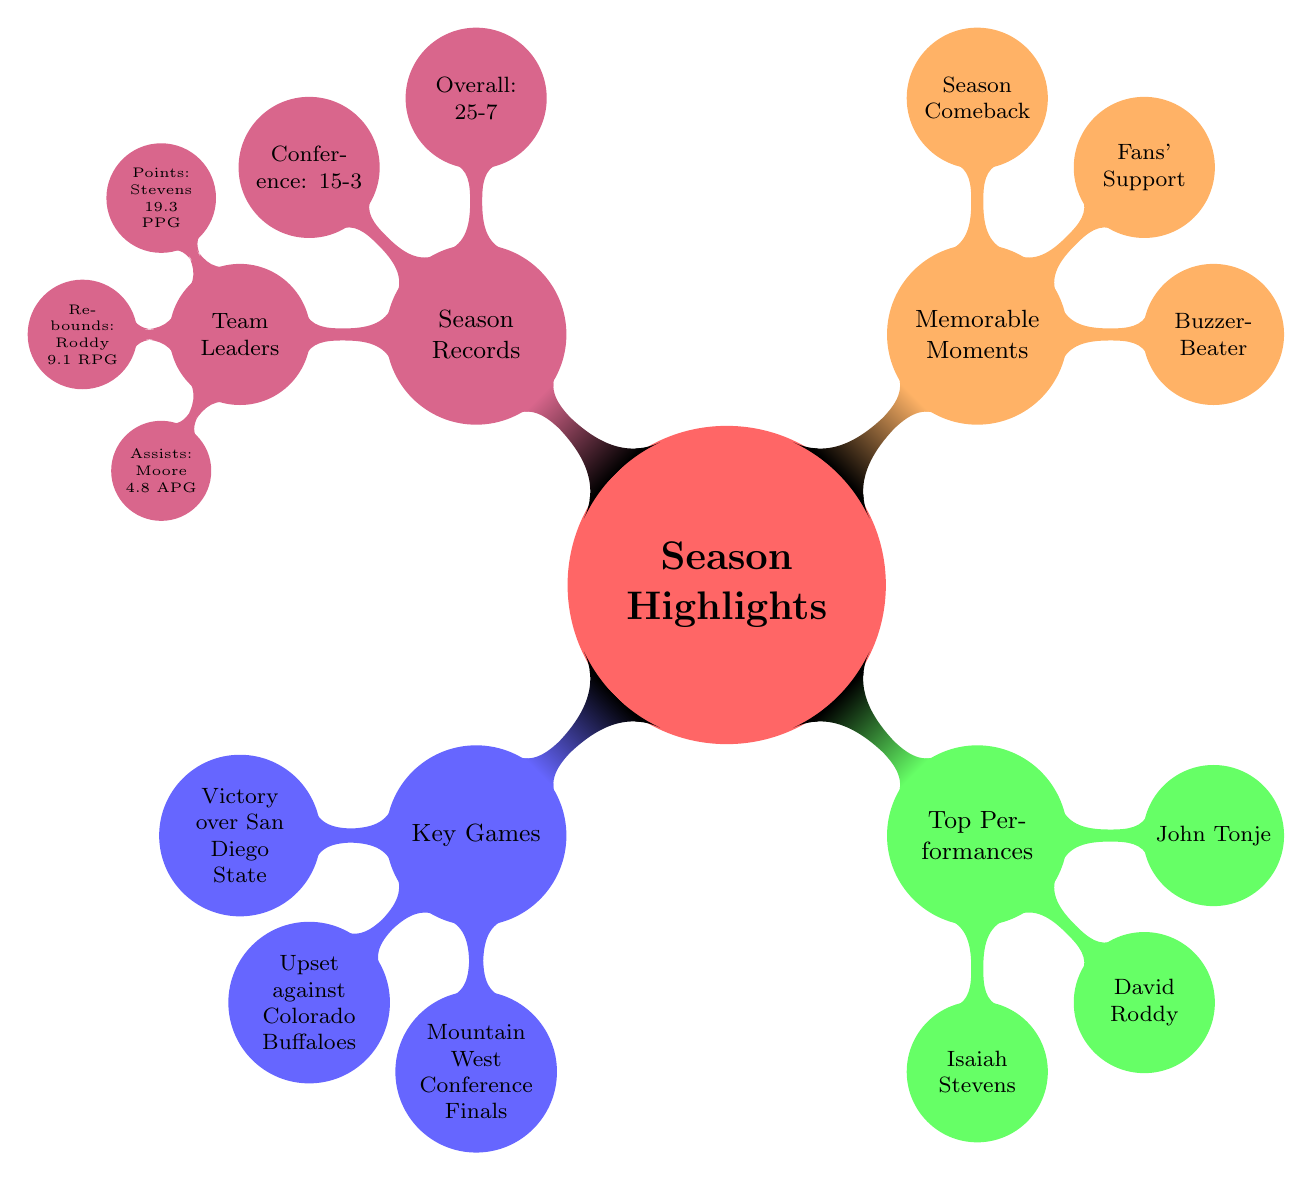What was the overall record of the Colorado State Rams this season? The overall record is directly listed under the "Season Records" section in the mind map. It states "Overall Record: 25-7." Therefore, the answer is simply the number provided in that node.
Answer: 25-7 Which player had a career-high of 32 points? The player with the career-high of 32 points is mentioned in the "Top Performances" section under "Isaiah Stevens." This node states "Career-high 32 points against Wyoming," which indicates that Isaiah Stevens achieved this milestone.
Answer: Isaiah Stevens What is the conference record of the team? The conference record is specified in the "Season Records" section. It directly states "Conference Record: 15-3," providing a straightforward answer that indicates the team's performance in their conference matches.
Answer: 15-3 Which game is described as a thrilling overtime victory? The game characterized as a thrilling overtime victory is found under the "Key Games" section, within the node "Upset against Colorado Buffaloes." This description specifically highlights the significance of that game.
Answer: Upset against Colorado Buffaloes Who averaged the most points per game this season? The mind map under "Season Records" outlines the team leader in points per game, stating "Points per Game: Isaiah Stevens with 19.3 PPG." Thus, the answer reflects the player who led the team in scoring.
Answer: Isaiah Stevens What memorable moment involved a comeback from a 20-point deficit? The memorable moment related to a significant comeback can be found under the "Memorable Moments" section, specifically within the node "Season Comeback," which highlights this remarkable achievement.
Answer: Season Comeback How many key games are highlighted in the diagram? To determine the number of key games, we can count the nodes under the "Key Games" section. There are three listed: "Victory over San Diego State," "Upset against Colorado Buffaloes," and "Mountain West Conference Finals." Therefore, the total number is three.
Answer: 3 Which player is noted for 20 points and 15 rebounds in a game? The information can be found under the "Top Performances" section, specifically stating "David Roddy: 20-point, 15-rebound double-double vs Boise State." Hence, this node identifies David Roddy as the player in question.
Answer: David Roddy 